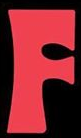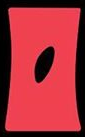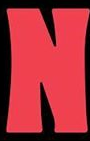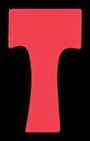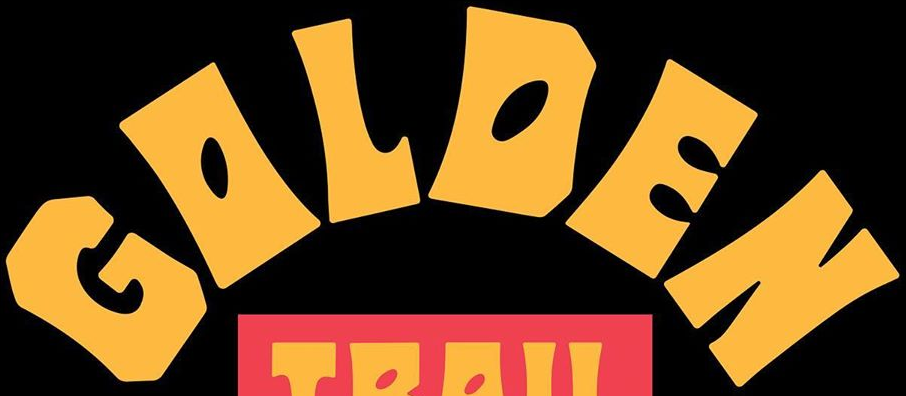Identify the words shown in these images in order, separated by a semicolon. F; O; N; T; GOLDEN 